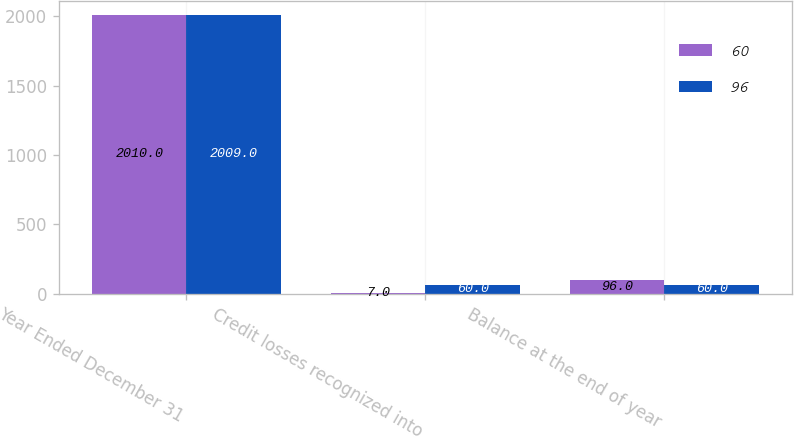Convert chart to OTSL. <chart><loc_0><loc_0><loc_500><loc_500><stacked_bar_chart><ecel><fcel>Year Ended December 31<fcel>Credit losses recognized into<fcel>Balance at the end of year<nl><fcel>60<fcel>2010<fcel>7<fcel>96<nl><fcel>96<fcel>2009<fcel>60<fcel>60<nl></chart> 